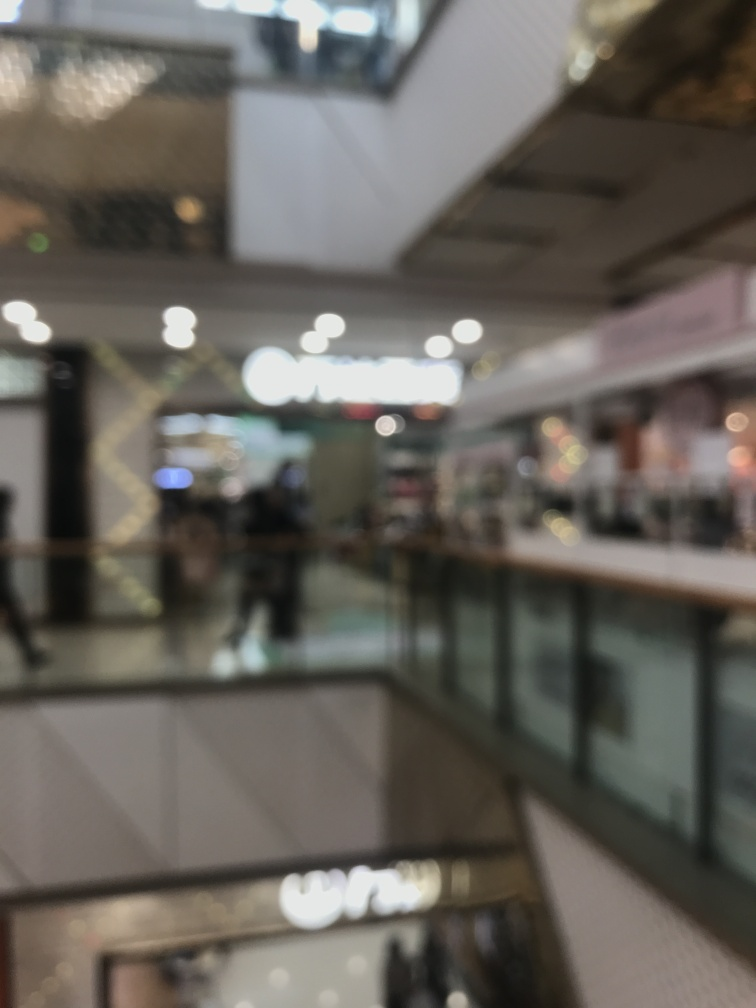Are there any people in this image, and if so, what can we infer about their actions? Yes, there are indistinct shapes that could be people in the image. Their actions are not clearly discernible due to the blurriness, but they seem to be standing or walking, likely engaging in typical behaviors one would expect in a public indoor setting, such as shopping or socializing. 